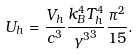<formula> <loc_0><loc_0><loc_500><loc_500>U _ { h } = \frac { V _ { h } } { c ^ { 3 } } \frac { k _ { B } ^ { 4 } T _ { h } ^ { 4 } } { { { \gamma } ^ { 3 } } ^ { 3 } } \frac { { \pi } ^ { 2 } } { 1 5 } .</formula> 